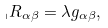<formula> <loc_0><loc_0><loc_500><loc_500>\ _ { \shortmid } R _ { \alpha \beta } = \lambda g _ { \alpha \beta } ,</formula> 